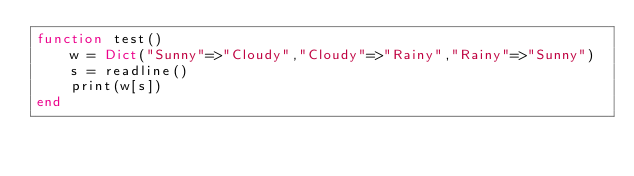<code> <loc_0><loc_0><loc_500><loc_500><_Julia_>function test()
    w = Dict("Sunny"=>"Cloudy","Cloudy"=>"Rainy","Rainy"=>"Sunny")
    s = readline()
    print(w[s])
end

</code> 